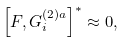Convert formula to latex. <formula><loc_0><loc_0><loc_500><loc_500>\left [ F , G _ { i } ^ { ( 2 ) a } \right ] ^ { * } \approx 0 ,</formula> 